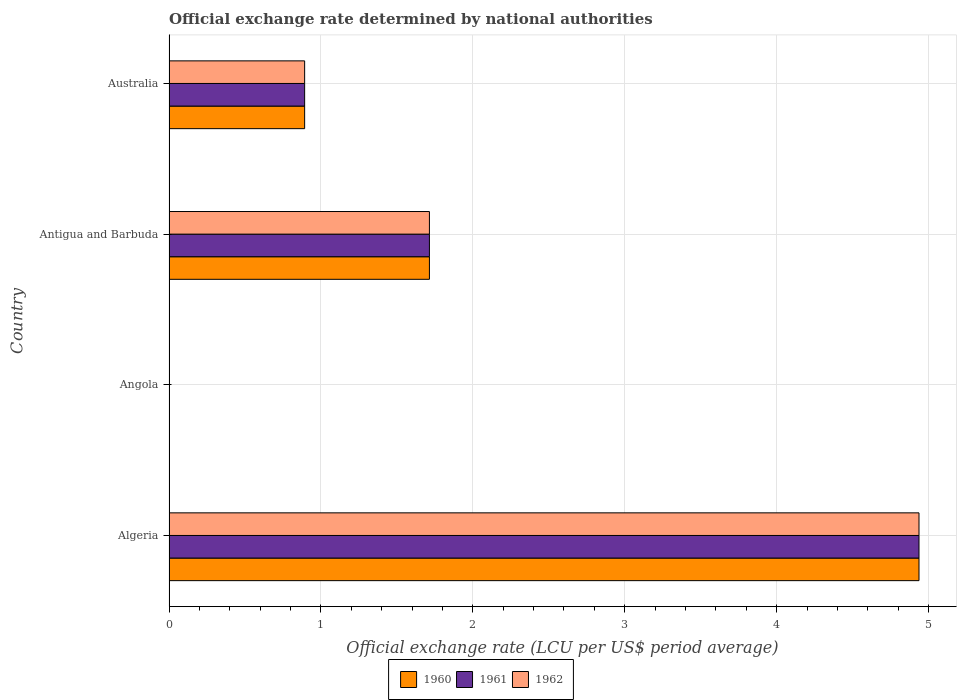Are the number of bars per tick equal to the number of legend labels?
Provide a short and direct response. Yes. How many bars are there on the 2nd tick from the bottom?
Make the answer very short. 3. What is the label of the 1st group of bars from the top?
Give a very brief answer. Australia. In how many cases, is the number of bars for a given country not equal to the number of legend labels?
Your answer should be compact. 0. What is the official exchange rate in 1962 in Algeria?
Provide a succinct answer. 4.94. Across all countries, what is the maximum official exchange rate in 1961?
Keep it short and to the point. 4.94. Across all countries, what is the minimum official exchange rate in 1960?
Give a very brief answer. 2.86684433333333e-8. In which country was the official exchange rate in 1960 maximum?
Provide a short and direct response. Algeria. In which country was the official exchange rate in 1961 minimum?
Make the answer very short. Angola. What is the total official exchange rate in 1962 in the graph?
Your answer should be very brief. 7.54. What is the difference between the official exchange rate in 1960 in Antigua and Barbuda and that in Australia?
Offer a terse response. 0.82. What is the difference between the official exchange rate in 1960 in Australia and the official exchange rate in 1962 in Angola?
Offer a very short reply. 0.89. What is the average official exchange rate in 1961 per country?
Make the answer very short. 1.89. In how many countries, is the official exchange rate in 1962 greater than 3.4 LCU?
Provide a succinct answer. 1. What is the ratio of the official exchange rate in 1960 in Angola to that in Antigua and Barbuda?
Your response must be concise. 1.672321679610105e-8. Is the difference between the official exchange rate in 1961 in Algeria and Antigua and Barbuda greater than the difference between the official exchange rate in 1962 in Algeria and Antigua and Barbuda?
Your response must be concise. No. What is the difference between the highest and the second highest official exchange rate in 1962?
Your answer should be very brief. 3.22. What is the difference between the highest and the lowest official exchange rate in 1961?
Keep it short and to the point. 4.94. In how many countries, is the official exchange rate in 1961 greater than the average official exchange rate in 1961 taken over all countries?
Offer a very short reply. 1. Is the sum of the official exchange rate in 1960 in Algeria and Angola greater than the maximum official exchange rate in 1962 across all countries?
Offer a very short reply. Yes. What does the 2nd bar from the top in Algeria represents?
Offer a very short reply. 1961. Is it the case that in every country, the sum of the official exchange rate in 1962 and official exchange rate in 1961 is greater than the official exchange rate in 1960?
Give a very brief answer. Yes. Are all the bars in the graph horizontal?
Your response must be concise. Yes. How many countries are there in the graph?
Give a very brief answer. 4. What is the difference between two consecutive major ticks on the X-axis?
Offer a terse response. 1. Where does the legend appear in the graph?
Ensure brevity in your answer.  Bottom center. How are the legend labels stacked?
Your answer should be compact. Horizontal. What is the title of the graph?
Provide a short and direct response. Official exchange rate determined by national authorities. Does "2003" appear as one of the legend labels in the graph?
Make the answer very short. No. What is the label or title of the X-axis?
Your answer should be compact. Official exchange rate (LCU per US$ period average). What is the Official exchange rate (LCU per US$ period average) of 1960 in Algeria?
Provide a short and direct response. 4.94. What is the Official exchange rate (LCU per US$ period average) of 1961 in Algeria?
Offer a terse response. 4.94. What is the Official exchange rate (LCU per US$ period average) of 1962 in Algeria?
Make the answer very short. 4.94. What is the Official exchange rate (LCU per US$ period average) in 1960 in Angola?
Keep it short and to the point. 2.86684433333333e-8. What is the Official exchange rate (LCU per US$ period average) of 1961 in Angola?
Your answer should be compact. 2.873486e-8. What is the Official exchange rate (LCU per US$ period average) in 1962 in Angola?
Give a very brief answer. 2.86784433333333e-8. What is the Official exchange rate (LCU per US$ period average) in 1960 in Antigua and Barbuda?
Your answer should be compact. 1.71. What is the Official exchange rate (LCU per US$ period average) in 1961 in Antigua and Barbuda?
Ensure brevity in your answer.  1.71. What is the Official exchange rate (LCU per US$ period average) of 1962 in Antigua and Barbuda?
Offer a terse response. 1.71. What is the Official exchange rate (LCU per US$ period average) of 1960 in Australia?
Your answer should be very brief. 0.89. What is the Official exchange rate (LCU per US$ period average) in 1961 in Australia?
Provide a succinct answer. 0.89. What is the Official exchange rate (LCU per US$ period average) of 1962 in Australia?
Give a very brief answer. 0.89. Across all countries, what is the maximum Official exchange rate (LCU per US$ period average) of 1960?
Your answer should be compact. 4.94. Across all countries, what is the maximum Official exchange rate (LCU per US$ period average) of 1961?
Ensure brevity in your answer.  4.94. Across all countries, what is the maximum Official exchange rate (LCU per US$ period average) in 1962?
Make the answer very short. 4.94. Across all countries, what is the minimum Official exchange rate (LCU per US$ period average) in 1960?
Your answer should be very brief. 2.86684433333333e-8. Across all countries, what is the minimum Official exchange rate (LCU per US$ period average) of 1961?
Your response must be concise. 2.873486e-8. Across all countries, what is the minimum Official exchange rate (LCU per US$ period average) of 1962?
Ensure brevity in your answer.  2.86784433333333e-8. What is the total Official exchange rate (LCU per US$ period average) in 1960 in the graph?
Provide a succinct answer. 7.54. What is the total Official exchange rate (LCU per US$ period average) in 1961 in the graph?
Ensure brevity in your answer.  7.54. What is the total Official exchange rate (LCU per US$ period average) of 1962 in the graph?
Offer a terse response. 7.54. What is the difference between the Official exchange rate (LCU per US$ period average) of 1960 in Algeria and that in Angola?
Keep it short and to the point. 4.94. What is the difference between the Official exchange rate (LCU per US$ period average) in 1961 in Algeria and that in Angola?
Keep it short and to the point. 4.94. What is the difference between the Official exchange rate (LCU per US$ period average) in 1962 in Algeria and that in Angola?
Make the answer very short. 4.94. What is the difference between the Official exchange rate (LCU per US$ period average) in 1960 in Algeria and that in Antigua and Barbuda?
Your answer should be very brief. 3.22. What is the difference between the Official exchange rate (LCU per US$ period average) of 1961 in Algeria and that in Antigua and Barbuda?
Offer a terse response. 3.22. What is the difference between the Official exchange rate (LCU per US$ period average) of 1962 in Algeria and that in Antigua and Barbuda?
Make the answer very short. 3.22. What is the difference between the Official exchange rate (LCU per US$ period average) in 1960 in Algeria and that in Australia?
Provide a short and direct response. 4.04. What is the difference between the Official exchange rate (LCU per US$ period average) in 1961 in Algeria and that in Australia?
Provide a succinct answer. 4.04. What is the difference between the Official exchange rate (LCU per US$ period average) of 1962 in Algeria and that in Australia?
Your response must be concise. 4.04. What is the difference between the Official exchange rate (LCU per US$ period average) of 1960 in Angola and that in Antigua and Barbuda?
Your answer should be very brief. -1.71. What is the difference between the Official exchange rate (LCU per US$ period average) of 1961 in Angola and that in Antigua and Barbuda?
Give a very brief answer. -1.71. What is the difference between the Official exchange rate (LCU per US$ period average) in 1962 in Angola and that in Antigua and Barbuda?
Make the answer very short. -1.71. What is the difference between the Official exchange rate (LCU per US$ period average) of 1960 in Angola and that in Australia?
Offer a terse response. -0.89. What is the difference between the Official exchange rate (LCU per US$ period average) in 1961 in Angola and that in Australia?
Keep it short and to the point. -0.89. What is the difference between the Official exchange rate (LCU per US$ period average) in 1962 in Angola and that in Australia?
Provide a short and direct response. -0.89. What is the difference between the Official exchange rate (LCU per US$ period average) in 1960 in Antigua and Barbuda and that in Australia?
Your answer should be compact. 0.82. What is the difference between the Official exchange rate (LCU per US$ period average) in 1961 in Antigua and Barbuda and that in Australia?
Offer a terse response. 0.82. What is the difference between the Official exchange rate (LCU per US$ period average) of 1962 in Antigua and Barbuda and that in Australia?
Your answer should be very brief. 0.82. What is the difference between the Official exchange rate (LCU per US$ period average) in 1960 in Algeria and the Official exchange rate (LCU per US$ period average) in 1961 in Angola?
Provide a succinct answer. 4.94. What is the difference between the Official exchange rate (LCU per US$ period average) in 1960 in Algeria and the Official exchange rate (LCU per US$ period average) in 1962 in Angola?
Give a very brief answer. 4.94. What is the difference between the Official exchange rate (LCU per US$ period average) of 1961 in Algeria and the Official exchange rate (LCU per US$ period average) of 1962 in Angola?
Provide a short and direct response. 4.94. What is the difference between the Official exchange rate (LCU per US$ period average) in 1960 in Algeria and the Official exchange rate (LCU per US$ period average) in 1961 in Antigua and Barbuda?
Your answer should be compact. 3.22. What is the difference between the Official exchange rate (LCU per US$ period average) in 1960 in Algeria and the Official exchange rate (LCU per US$ period average) in 1962 in Antigua and Barbuda?
Keep it short and to the point. 3.22. What is the difference between the Official exchange rate (LCU per US$ period average) in 1961 in Algeria and the Official exchange rate (LCU per US$ period average) in 1962 in Antigua and Barbuda?
Give a very brief answer. 3.22. What is the difference between the Official exchange rate (LCU per US$ period average) of 1960 in Algeria and the Official exchange rate (LCU per US$ period average) of 1961 in Australia?
Your response must be concise. 4.04. What is the difference between the Official exchange rate (LCU per US$ period average) of 1960 in Algeria and the Official exchange rate (LCU per US$ period average) of 1962 in Australia?
Give a very brief answer. 4.04. What is the difference between the Official exchange rate (LCU per US$ period average) in 1961 in Algeria and the Official exchange rate (LCU per US$ period average) in 1962 in Australia?
Offer a very short reply. 4.04. What is the difference between the Official exchange rate (LCU per US$ period average) in 1960 in Angola and the Official exchange rate (LCU per US$ period average) in 1961 in Antigua and Barbuda?
Your response must be concise. -1.71. What is the difference between the Official exchange rate (LCU per US$ period average) in 1960 in Angola and the Official exchange rate (LCU per US$ period average) in 1962 in Antigua and Barbuda?
Make the answer very short. -1.71. What is the difference between the Official exchange rate (LCU per US$ period average) of 1961 in Angola and the Official exchange rate (LCU per US$ period average) of 1962 in Antigua and Barbuda?
Your answer should be compact. -1.71. What is the difference between the Official exchange rate (LCU per US$ period average) in 1960 in Angola and the Official exchange rate (LCU per US$ period average) in 1961 in Australia?
Keep it short and to the point. -0.89. What is the difference between the Official exchange rate (LCU per US$ period average) in 1960 in Angola and the Official exchange rate (LCU per US$ period average) in 1962 in Australia?
Ensure brevity in your answer.  -0.89. What is the difference between the Official exchange rate (LCU per US$ period average) of 1961 in Angola and the Official exchange rate (LCU per US$ period average) of 1962 in Australia?
Your answer should be very brief. -0.89. What is the difference between the Official exchange rate (LCU per US$ period average) in 1960 in Antigua and Barbuda and the Official exchange rate (LCU per US$ period average) in 1961 in Australia?
Provide a short and direct response. 0.82. What is the difference between the Official exchange rate (LCU per US$ period average) in 1960 in Antigua and Barbuda and the Official exchange rate (LCU per US$ period average) in 1962 in Australia?
Keep it short and to the point. 0.82. What is the difference between the Official exchange rate (LCU per US$ period average) of 1961 in Antigua and Barbuda and the Official exchange rate (LCU per US$ period average) of 1962 in Australia?
Provide a succinct answer. 0.82. What is the average Official exchange rate (LCU per US$ period average) of 1960 per country?
Keep it short and to the point. 1.89. What is the average Official exchange rate (LCU per US$ period average) in 1961 per country?
Your answer should be compact. 1.89. What is the average Official exchange rate (LCU per US$ period average) in 1962 per country?
Offer a very short reply. 1.89. What is the difference between the Official exchange rate (LCU per US$ period average) of 1960 and Official exchange rate (LCU per US$ period average) of 1962 in Angola?
Make the answer very short. -0. What is the difference between the Official exchange rate (LCU per US$ period average) in 1960 and Official exchange rate (LCU per US$ period average) in 1961 in Antigua and Barbuda?
Provide a succinct answer. 0. What is the difference between the Official exchange rate (LCU per US$ period average) of 1960 and Official exchange rate (LCU per US$ period average) of 1962 in Australia?
Give a very brief answer. 0. What is the ratio of the Official exchange rate (LCU per US$ period average) of 1960 in Algeria to that in Angola?
Provide a short and direct response. 1.72e+08. What is the ratio of the Official exchange rate (LCU per US$ period average) of 1961 in Algeria to that in Angola?
Provide a succinct answer. 1.72e+08. What is the ratio of the Official exchange rate (LCU per US$ period average) of 1962 in Algeria to that in Angola?
Make the answer very short. 1.72e+08. What is the ratio of the Official exchange rate (LCU per US$ period average) in 1960 in Algeria to that in Antigua and Barbuda?
Your response must be concise. 2.88. What is the ratio of the Official exchange rate (LCU per US$ period average) of 1961 in Algeria to that in Antigua and Barbuda?
Offer a very short reply. 2.88. What is the ratio of the Official exchange rate (LCU per US$ period average) in 1962 in Algeria to that in Antigua and Barbuda?
Give a very brief answer. 2.88. What is the ratio of the Official exchange rate (LCU per US$ period average) of 1960 in Algeria to that in Australia?
Your answer should be compact. 5.53. What is the ratio of the Official exchange rate (LCU per US$ period average) of 1961 in Algeria to that in Australia?
Make the answer very short. 5.53. What is the ratio of the Official exchange rate (LCU per US$ period average) of 1962 in Algeria to that in Australia?
Offer a very short reply. 5.53. What is the ratio of the Official exchange rate (LCU per US$ period average) in 1962 in Angola to that in Antigua and Barbuda?
Offer a very short reply. 0. What is the ratio of the Official exchange rate (LCU per US$ period average) in 1960 in Angola to that in Australia?
Your answer should be compact. 0. What is the ratio of the Official exchange rate (LCU per US$ period average) of 1961 in Angola to that in Australia?
Make the answer very short. 0. What is the ratio of the Official exchange rate (LCU per US$ period average) of 1962 in Angola to that in Australia?
Ensure brevity in your answer.  0. What is the ratio of the Official exchange rate (LCU per US$ period average) in 1960 in Antigua and Barbuda to that in Australia?
Your response must be concise. 1.92. What is the ratio of the Official exchange rate (LCU per US$ period average) of 1961 in Antigua and Barbuda to that in Australia?
Provide a short and direct response. 1.92. What is the ratio of the Official exchange rate (LCU per US$ period average) of 1962 in Antigua and Barbuda to that in Australia?
Keep it short and to the point. 1.92. What is the difference between the highest and the second highest Official exchange rate (LCU per US$ period average) of 1960?
Make the answer very short. 3.22. What is the difference between the highest and the second highest Official exchange rate (LCU per US$ period average) in 1961?
Provide a succinct answer. 3.22. What is the difference between the highest and the second highest Official exchange rate (LCU per US$ period average) in 1962?
Your answer should be compact. 3.22. What is the difference between the highest and the lowest Official exchange rate (LCU per US$ period average) in 1960?
Make the answer very short. 4.94. What is the difference between the highest and the lowest Official exchange rate (LCU per US$ period average) of 1961?
Make the answer very short. 4.94. What is the difference between the highest and the lowest Official exchange rate (LCU per US$ period average) in 1962?
Keep it short and to the point. 4.94. 